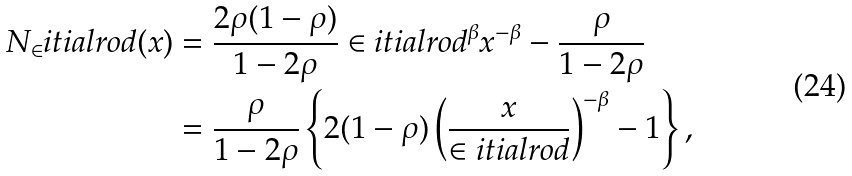<formula> <loc_0><loc_0><loc_500><loc_500>N _ { \in } i t i a l r o d ( x ) & = \frac { 2 \rho ( 1 - \rho ) } { 1 - 2 \rho } \in i t i a l r o d ^ { \beta } x ^ { - \beta } - \frac { \rho } { 1 - 2 \rho } \\ & = \frac { \rho } { 1 - 2 \rho } \left \{ 2 ( 1 - \rho ) \left ( \frac { x } { \in i t i a l r o d } \right ) ^ { - \beta } - 1 \right \} ,</formula> 